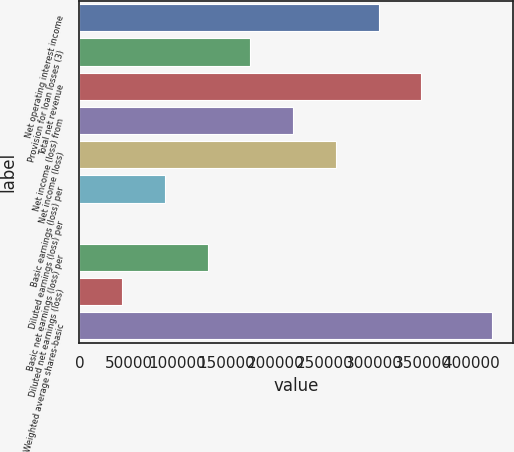Convert chart. <chart><loc_0><loc_0><loc_500><loc_500><bar_chart><fcel>Net operating interest income<fcel>Provision for loan losses (3)<fcel>Total net revenue<fcel>Net income (loss) from<fcel>Net income (loss)<fcel>Basic earnings (loss) per<fcel>Diluted earnings (loss) per<fcel>Basic net earnings (loss) per<fcel>Diluted net earnings (loss)<fcel>Weighted average shares-basic<nl><fcel>305450<fcel>174544<fcel>349086<fcel>218179<fcel>261815<fcel>87272.6<fcel>1.44<fcel>130908<fcel>43637<fcel>421127<nl></chart> 